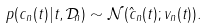<formula> <loc_0><loc_0><loc_500><loc_500>p ( c _ { n } ( t ) | t , \mathcal { D } _ { n } ) \sim \mathcal { N } ( \hat { c } _ { n } ( t ) ; v _ { n } ( t ) ) .</formula> 